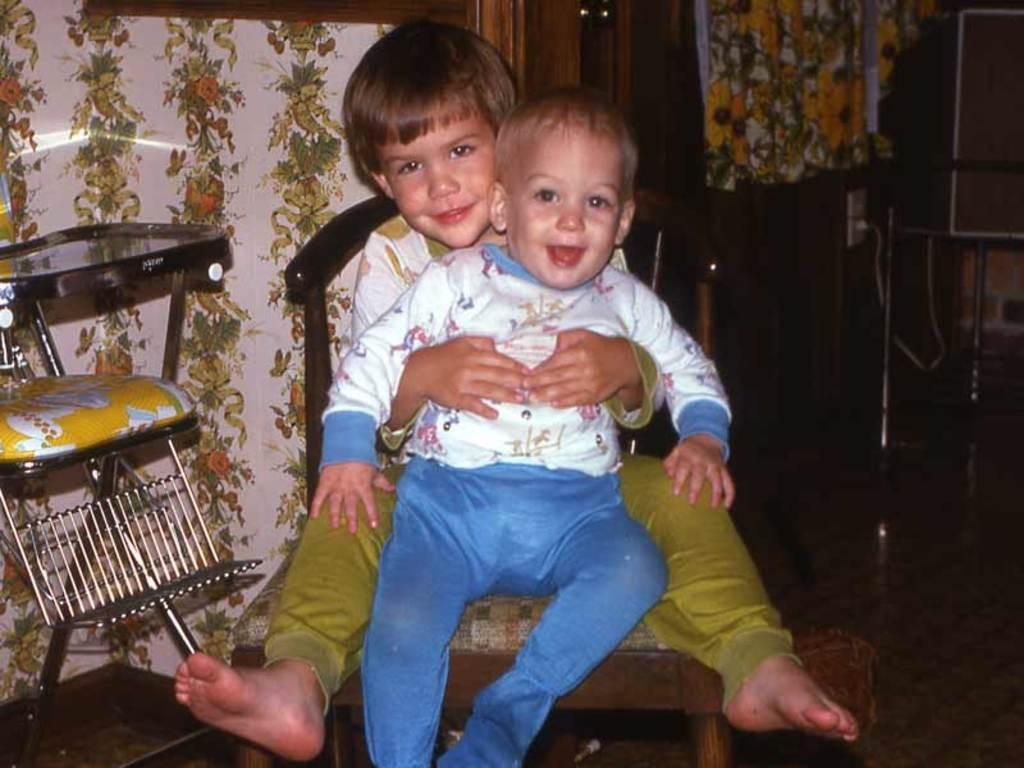Could you give a brief overview of what you see in this image? There are two kids sitting on a chair behind a iron stand. 